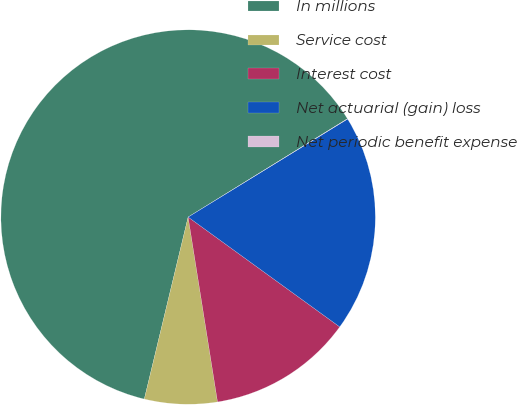Convert chart. <chart><loc_0><loc_0><loc_500><loc_500><pie_chart><fcel>In millions<fcel>Service cost<fcel>Interest cost<fcel>Net actuarial (gain) loss<fcel>Net periodic benefit expense<nl><fcel>62.44%<fcel>6.27%<fcel>12.51%<fcel>18.75%<fcel>0.03%<nl></chart> 